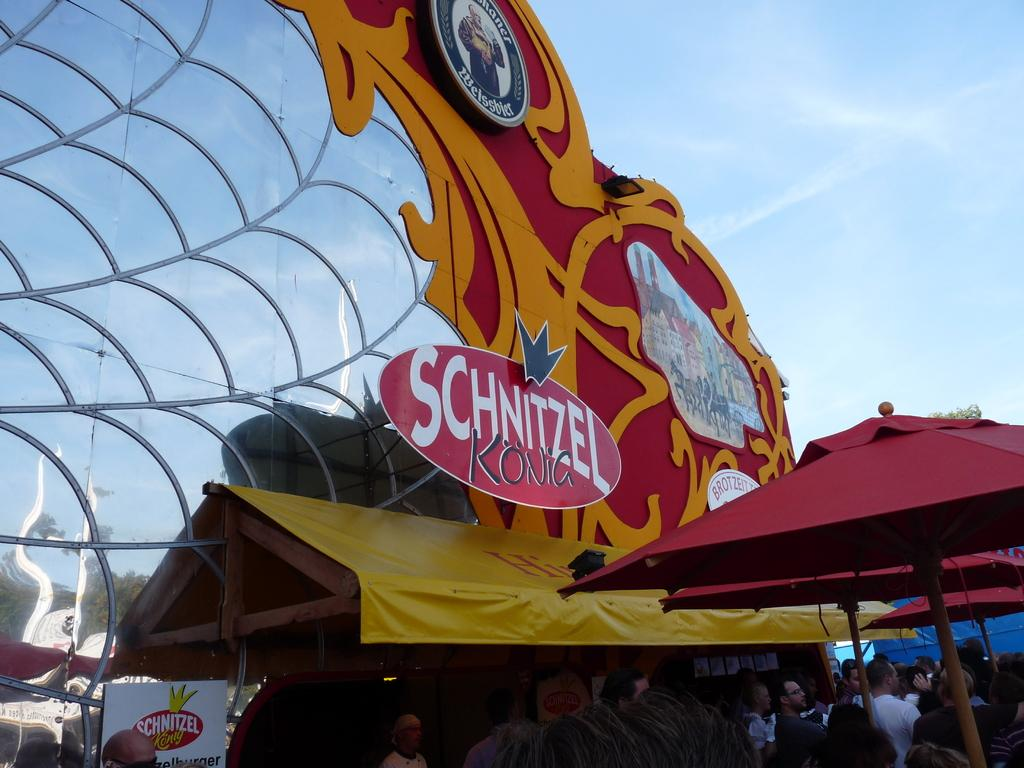<image>
Summarize the visual content of the image. An amusement park food stand is labeled Schnitzel Kong. 